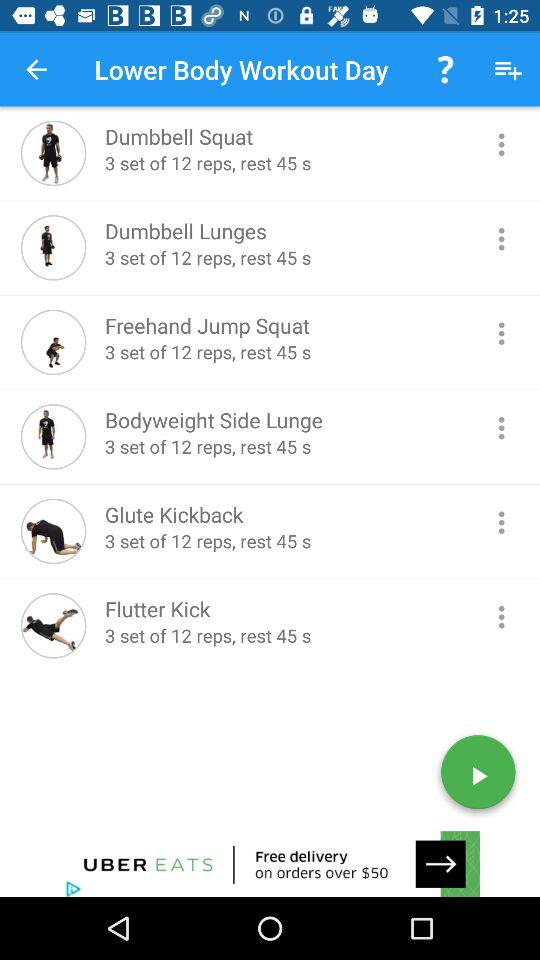How many exercises are in the lower body workout?
Answer the question using a single word or phrase. 6 